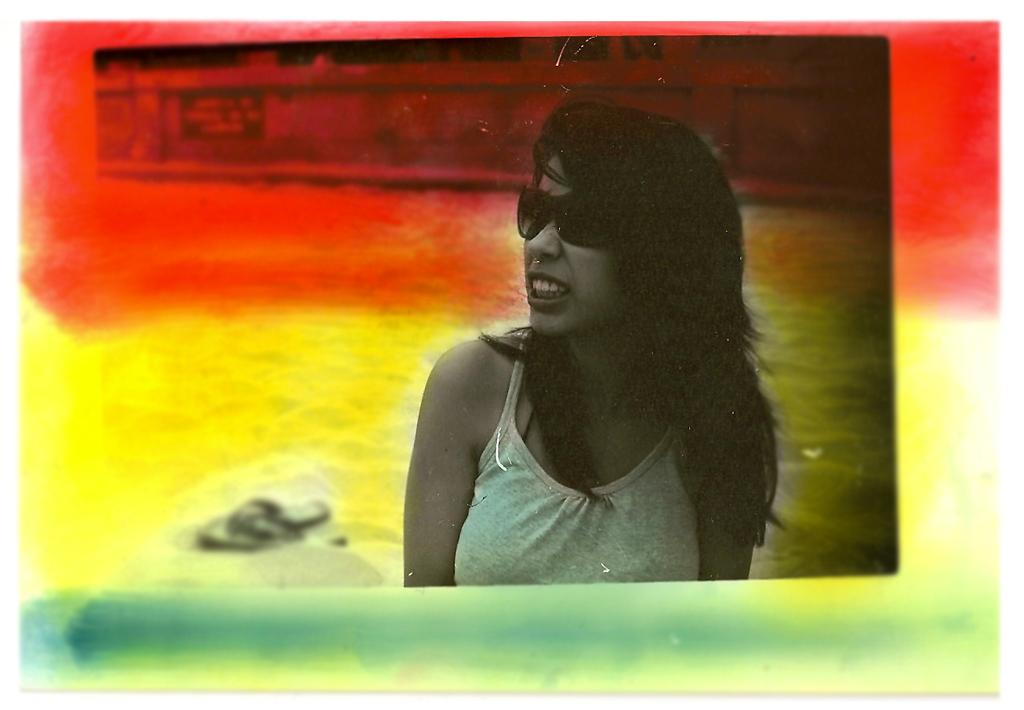What type of object is present in the picture? There is a colorful frame in the picture. Who or what can be seen within the frame? There is a woman visible within the frame. What is placed beside the frame? There is an object placed beside the frame. Reasoning: Let'g: Let's think step by step in order to produce the conversation. We start by identifying the main object in the picture, which is the colorful frame. Then, we describe what or who is inside the frame, which is a woman. Finally, we mention the presence of an object beside the frame, without specifying its nature. Each question is designed to elicit a specific detail about the image that is known from the provided facts. Absurd Question/Answer: What type of lock is securing the frame in the image? There is no lock visible in the image; the frame is not secured with a lock. What type of border is surrounding the frame in the image? There is no border surrounding the frame in the image; the frame itself is the colorful object. 